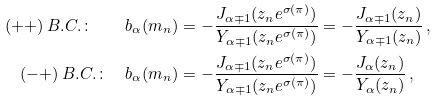<formula> <loc_0><loc_0><loc_500><loc_500>( + + ) \, B . C . \colon \quad b _ { \alpha } ( m _ { n } ) & = - \frac { J _ { \alpha \mp 1 } ( z _ { n } e ^ { \sigma ( \pi ) } ) } { Y _ { \alpha \mp 1 } ( z _ { n } e ^ { \sigma ( \pi ) } ) } = - \frac { J _ { \alpha \mp 1 } ( z _ { n } ) } { Y _ { \alpha \mp 1 } ( z _ { n } ) } \, , \\ ( - + ) \, B . C . \colon \quad b _ { \alpha } ( m _ { n } ) & = - \frac { J _ { \alpha \mp 1 } ( z _ { n } e ^ { \sigma ( \pi ) } ) } { Y _ { \alpha \mp 1 } ( z _ { n } e ^ { \sigma ( \pi ) } ) } = - \frac { J _ { \alpha } ( z _ { n } ) } { Y _ { \alpha } ( z _ { n } ) } \, ,</formula> 